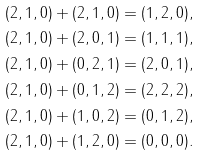<formula> <loc_0><loc_0><loc_500><loc_500>& ( 2 , 1 , 0 ) + ( 2 , 1 , 0 ) = ( 1 , 2 , 0 ) , \\ & ( 2 , 1 , 0 ) + ( 2 , 0 , 1 ) = ( 1 , 1 , 1 ) , \\ & ( 2 , 1 , 0 ) + ( 0 , 2 , 1 ) = ( 2 , 0 , 1 ) , \\ & ( 2 , 1 , 0 ) + ( 0 , 1 , 2 ) = ( 2 , 2 , 2 ) , \\ & ( 2 , 1 , 0 ) + ( 1 , 0 , 2 ) = ( 0 , 1 , 2 ) , \\ & ( 2 , 1 , 0 ) + ( 1 , 2 , 0 ) = ( 0 , 0 , 0 ) .</formula> 